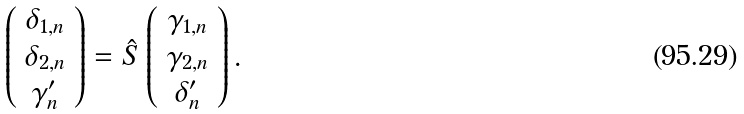<formula> <loc_0><loc_0><loc_500><loc_500>\left ( \begin{array} { c } \delta _ { 1 , n } \\ \delta _ { 2 , n } \\ \gamma ^ { \prime } _ { n } \end{array} \right ) = \hat { S } \left ( \begin{array} { c } \gamma _ { 1 , n } \\ \gamma _ { 2 , n } \\ \delta ^ { \prime } _ { n } \end{array} \right ) .</formula> 